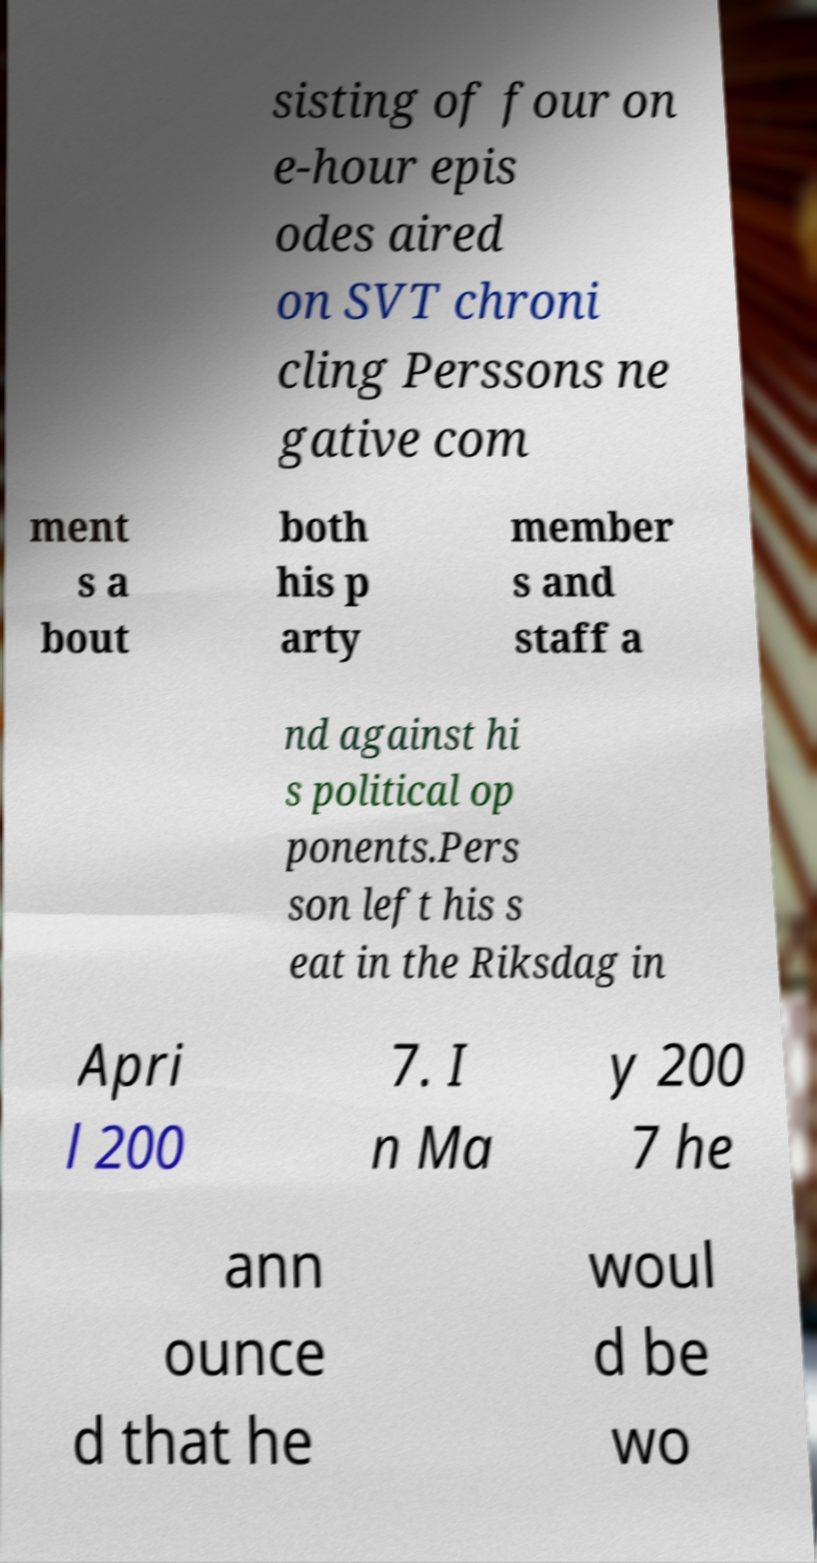I need the written content from this picture converted into text. Can you do that? sisting of four on e-hour epis odes aired on SVT chroni cling Perssons ne gative com ment s a bout both his p arty member s and staff a nd against hi s political op ponents.Pers son left his s eat in the Riksdag in Apri l 200 7. I n Ma y 200 7 he ann ounce d that he woul d be wo 